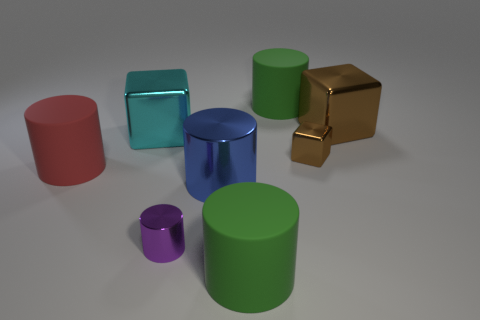What is the shape of the small brown thing that is made of the same material as the big blue object? cube 